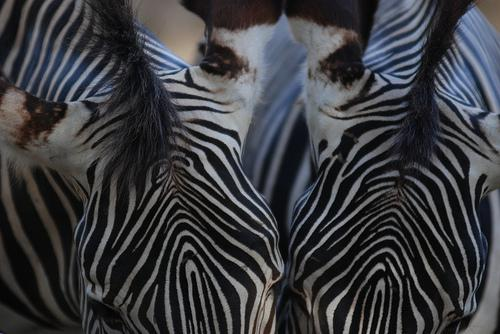Question: why can't the zebras faces be seen?
Choices:
A. They are looking away.
B. Heads are down.
C. They stand with their backs to us.
D. They are hiding faces in the grass.
Answer with the letter. Answer: B Question: how many zebras are there?
Choices:
A. 3.
B. 4.
C. 2.
D. 5.
Answer with the letter. Answer: C Question: what kind of animals are these?
Choices:
A. Jaguars.
B. Kangaroos.
C. Zebras.
D. Cheetas.
Answer with the letter. Answer: C 